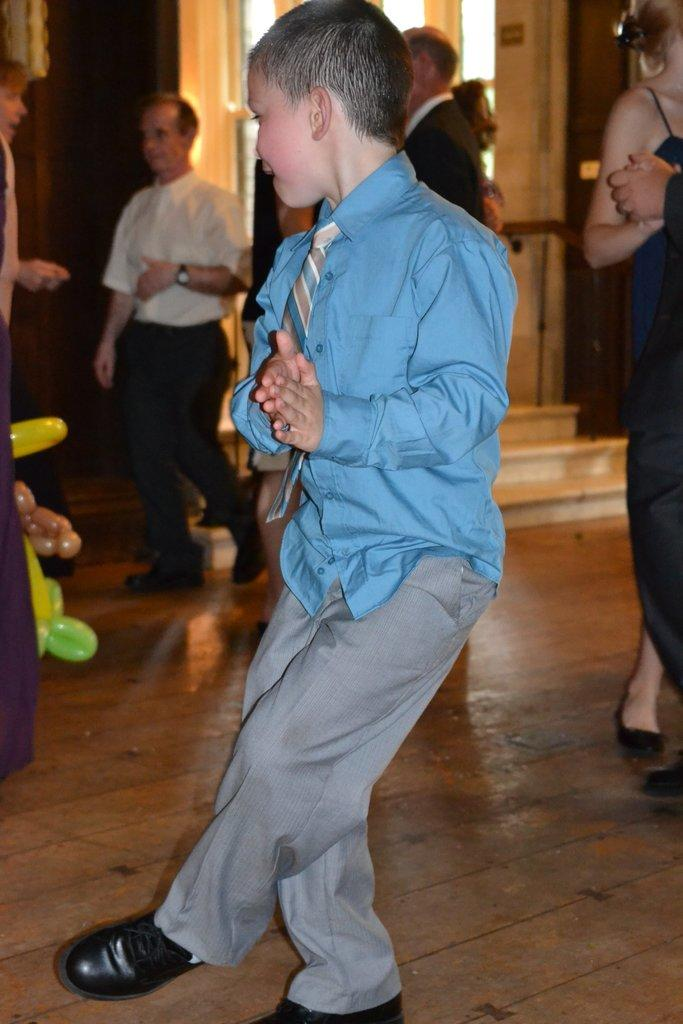What are the people in the image doing? There are people dancing on the floor in the image. Can you describe the actions of another person in the image? There is a man walking in the image. Are there any other people in the image who are not dancing or walking? Yes, there are people standing on the side in the image. What type of books can be found in the library depicted in the image? There is no library present in the image, so it is not possible to determine what type of books might be found there. 